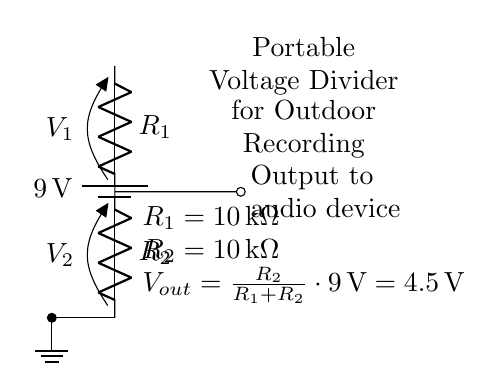What is the input voltage of the circuit? The input voltage is indicated as 9 volts from the battery.
Answer: 9 volts What are the resistor values used in the voltage divider? The values of the resistors are shown as both being 10 kilo-ohms.
Answer: 10 kilo-ohms What is the output voltage from the voltage divider? The output voltage is calculated using the voltage divider formula, yielding 4.5 volts when both resistors are equal.
Answer: 4.5 volts How many resistors are present in this circuit? There are two resistors, as clearly shown in the diagram.
Answer: 2 What would happen to the output voltage if R1 is increased to 20 kilo-ohms? Increasing R1 will result in the output voltage decreasing, as R2's ratio will change, affecting the voltage divider calculation. Let's calculate: Vout = (R2 / (R1 + R2)) * Vin = (10k / (20k + 10k)) * 9V = 3V.
Answer: 3 volts What is the purpose of the voltage divider in this circuit? The voltage divider is designed to reduce the higher battery voltage to a lower output voltage suitable for powering audio devices.
Answer: Powering audio devices What happens to Vout if R2 is removed? If R2 is removed, there would be no voltage division; hence, the output would be equal to the input voltage, which is 9 volts.
Answer: 9 volts 